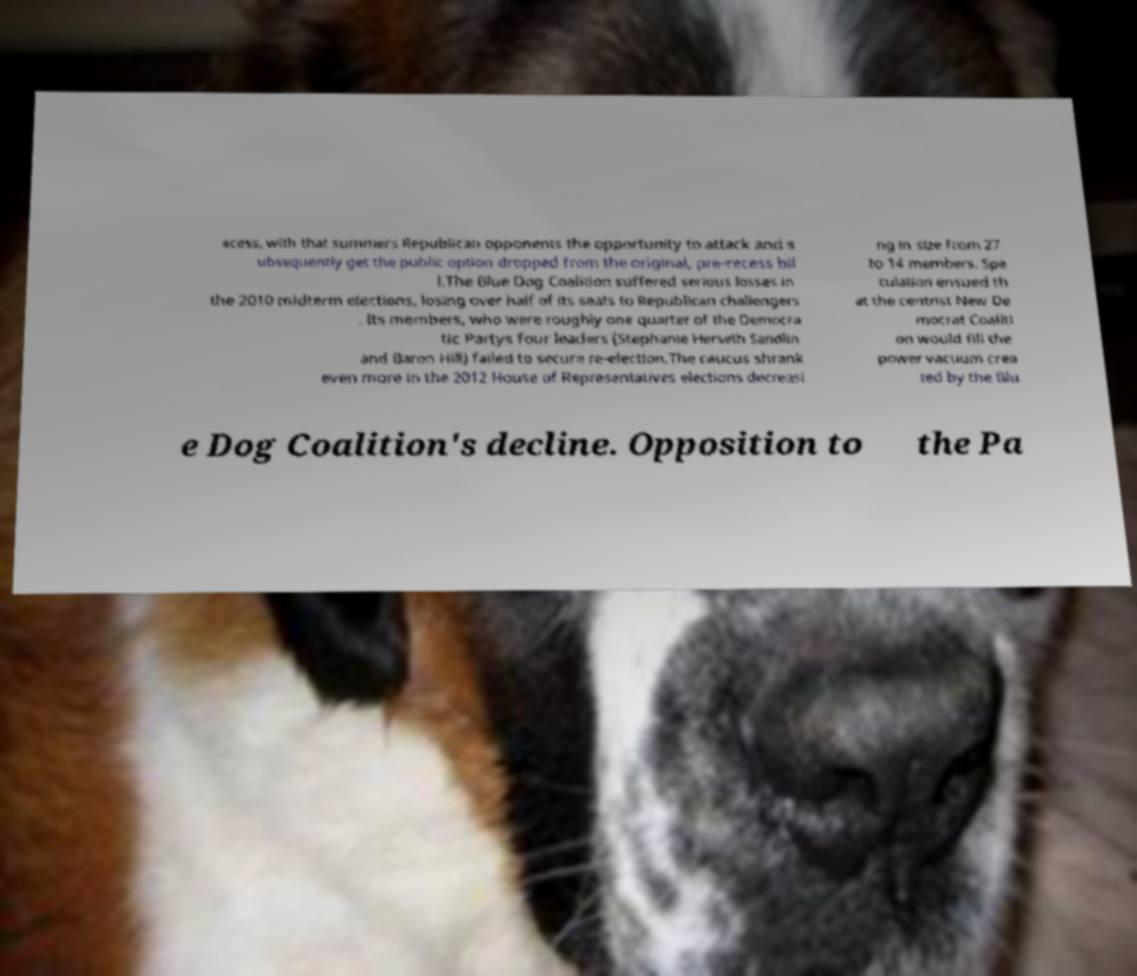I need the written content from this picture converted into text. Can you do that? ecess, with that summers Republican opponents the opportunity to attack and s ubsequently get the public option dropped from the original, pre-recess bil l.The Blue Dog Coalition suffered serious losses in the 2010 midterm elections, losing over half of its seats to Republican challengers . Its members, who were roughly one quarter of the Democra tic Partys four leaders (Stephanie Herseth Sandlin and Baron Hill) failed to secure re-election.The caucus shrank even more in the 2012 House of Representatives elections decreasi ng in size from 27 to 14 members. Spe culation ensued th at the centrist New De mocrat Coaliti on would fill the power vacuum crea ted by the Blu e Dog Coalition's decline. Opposition to the Pa 